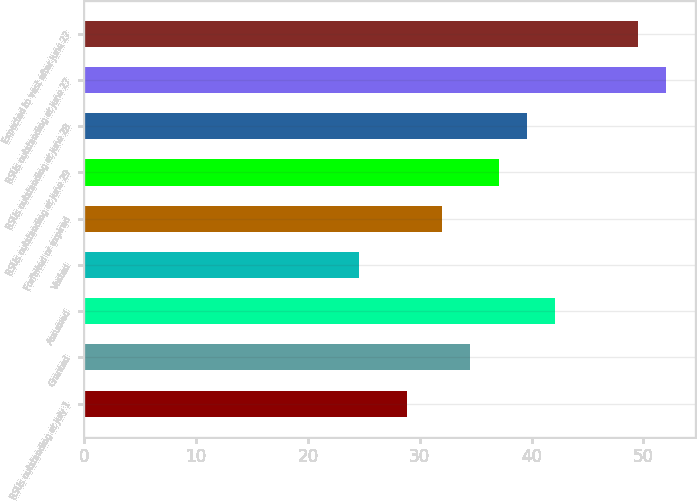<chart> <loc_0><loc_0><loc_500><loc_500><bar_chart><fcel>RSUs outstanding at July 1<fcel>Granted<fcel>Assumed<fcel>Vested<fcel>Forfeited or expired<fcel>RSUs outstanding at June 29<fcel>RSUs outstanding at June 28<fcel>RSUs outstanding at June 27<fcel>Expected to vest after June 27<nl><fcel>28.85<fcel>34.53<fcel>42.09<fcel>24.58<fcel>32.01<fcel>37.05<fcel>39.57<fcel>52<fcel>49.48<nl></chart> 